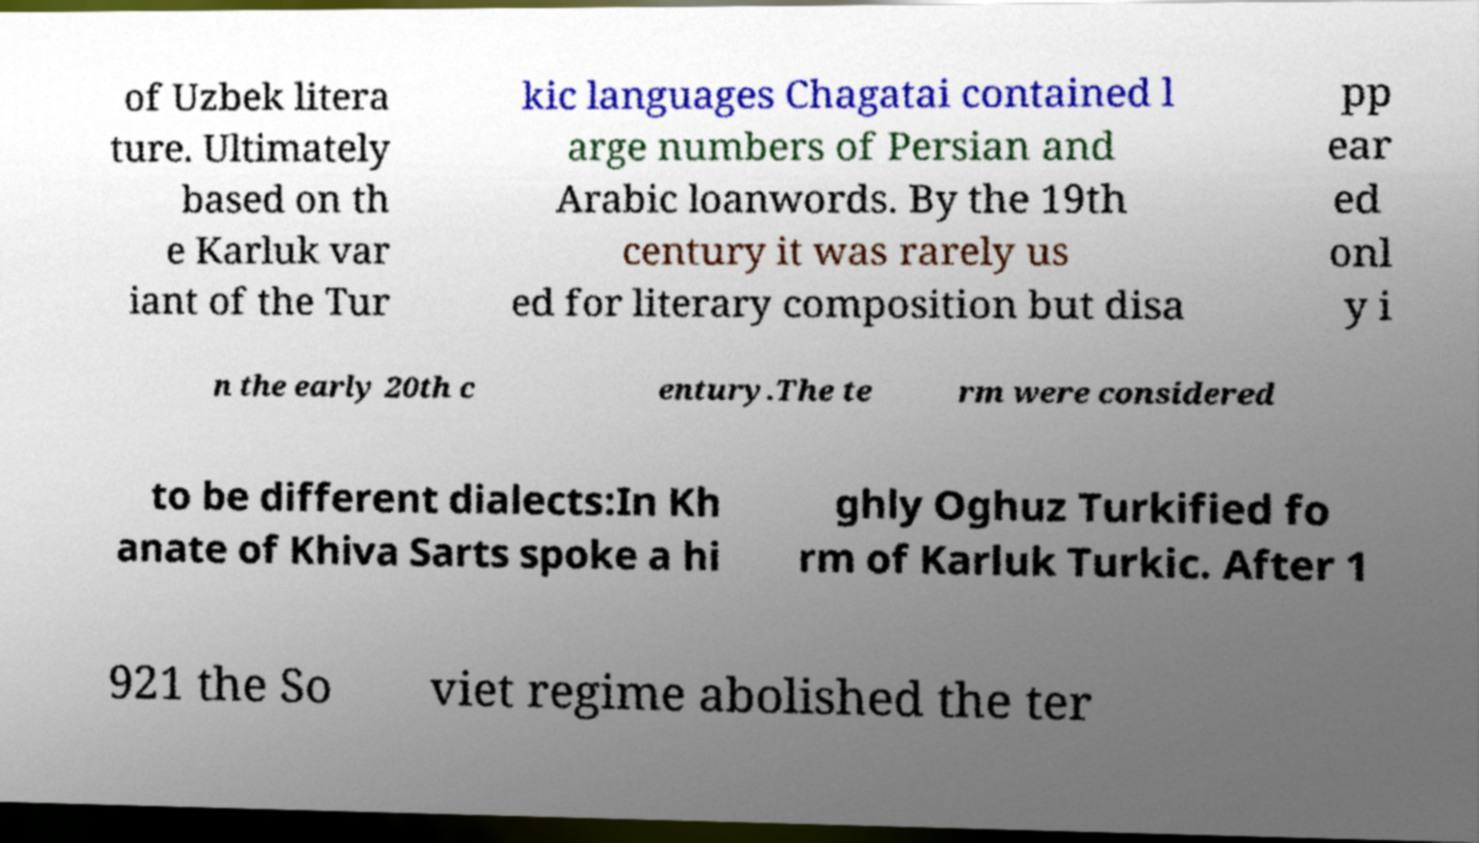For documentation purposes, I need the text within this image transcribed. Could you provide that? of Uzbek litera ture. Ultimately based on th e Karluk var iant of the Tur kic languages Chagatai contained l arge numbers of Persian and Arabic loanwords. By the 19th century it was rarely us ed for literary composition but disa pp ear ed onl y i n the early 20th c entury.The te rm were considered to be different dialects:In Kh anate of Khiva Sarts spoke a hi ghly Oghuz Turkified fo rm of Karluk Turkic. After 1 921 the So viet regime abolished the ter 